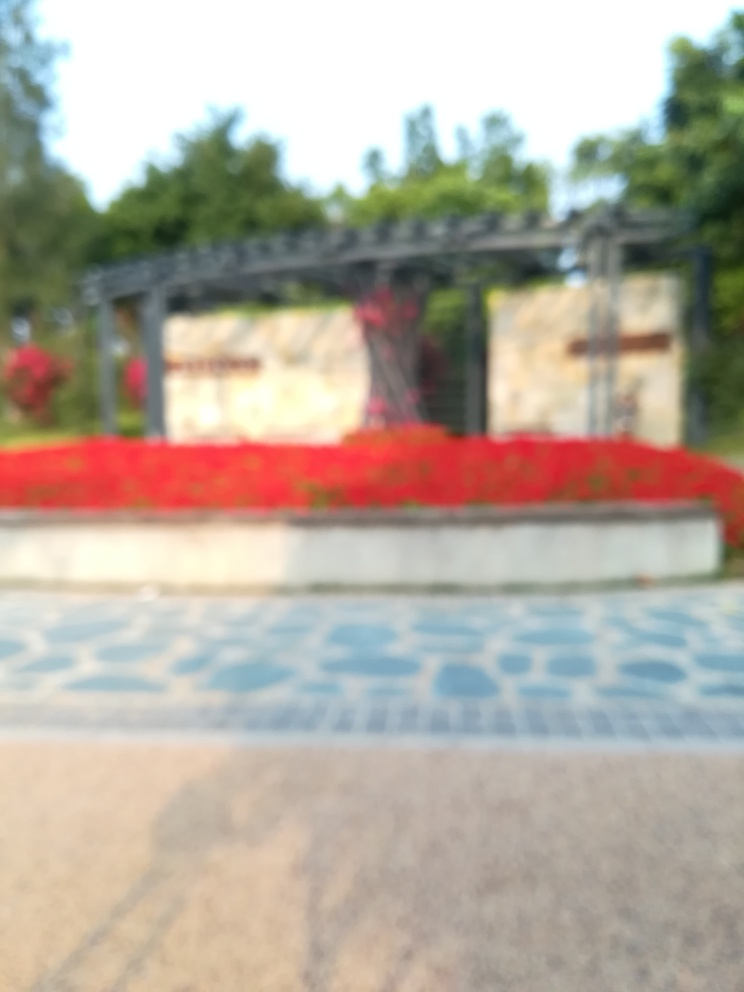What can you infer about the location shown in the image? The blurred image seems to feature a constructed archway with red elements which could be flowers, indicating a cultivated garden or park. The presence of a pathway or tiles on the ground hints at a space designed for visitors to walk through, possibly a public or a commemorative space. 